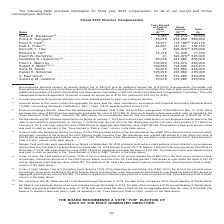According to Nortonlifelock's financial document, What does the table show? information for fiscal year 2019 compensation for all of our current and former non-employee directors. The document states: "The following table provides information for fiscal year 2019 compensation for all of our current and former non-employee directors:..." Also, What annual fee does The Lead Independent Director/Independent Chairman receive? $100,000 (reduced to $75,000 for 2020). The document states: "tor/Independent Chairman receives an annual fee of $100,000 (reduced to $75,000 for 2020)...." Also, Of the non-employee directors, who were not granted 12,320 RSUs on May 17, 2018? Ms. Barsamian and Messrs. Feld, Fuller, Hill and Miller. The document states: "(4) Each non-employee director, other than Ms. Barsamian and Messrs. Feld, Fuller, Hill and Miller, was granted 12,320 RSUs on May 17, 2018, with a pe..." Also, can you calculate: How much more in Director compensation did Frank E. Dangeard have over Susan P. Barsamian? Based on the calculation: 360,000-76,593, the result is 283407. This is based on the information: "210 (6) 76,593 Frank E. Dangeard . 85,018 274,982 360,000 Peter A. Feld (7) . 16,071 174,108 (8) 190,179 Dale L. Fuller (7) . 34,821 147,321 182,142 Kenneth Susan P. Barsamian (5) . 3,383 73,210 (6) 7..." The key data points involved are: 360,000, 76,593. Additionally, Who are compensated greater than $400,000 for total director compensation? According to the financial document, Daniel H. Schulman. The relevant text states: "5 245,274 Anita M. Sands . 70,018 274,982 345,000 Daniel H. Schulman . 195,018 274,982 470,000 V. Paul Unruh . 95,018 274,982 370,000 Suzanne M. Vautrinot . 70,018 274,..." Also, can you calculate: How much more in Director compensation did Peter A. Feld have over Dale L. Fuller? Based on the calculation: 190,179-182,142, the result is 8037. This is based on the information: "82 360,000 Peter A. Feld (7) . 16,071 174,108 (8) 190,179 Dale L. Fuller (7) . 34,821 147,321 182,142 Kenneth Y. Hao . 21 324,979 (9) 325,000 Richard S. Hill 8 (8) 190,179 Dale L. Fuller (7) . 34,821 ..." The key data points involved are: 182,142, 190,179. 